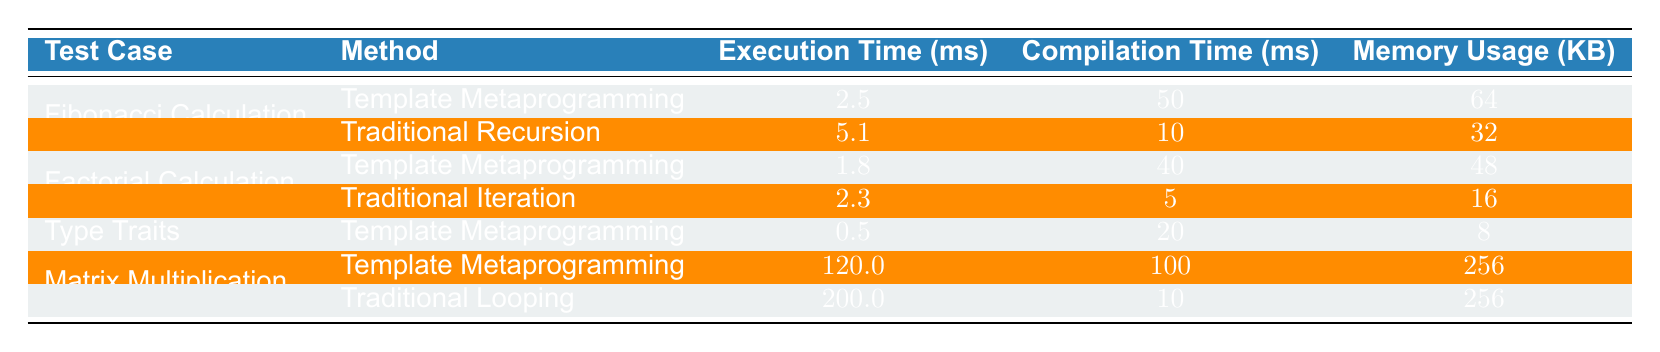What is the execution time for the `Factorial Calculation` using Template Metaprogramming? According to the table, for `Factorial Calculation` with `Template Metaprogramming`, the execution time is 1.8 ms.
Answer: 1.8 ms Which method has lower compilation time for `Matrix Multiplication`, Template Metaprogramming or Traditional Looping? The table shows that `Template Metaprogramming` has a compilation time of 100 ms, while `Traditional Looping` has a compilation time of 10 ms. Therefore, `Traditional Looping` has a lower compilation time.
Answer: Traditional Looping What is the average execution time of all the methods listed for `Fibonacci Calculation`? The execution times for `Fibonacci Calculation` are 2.5 ms (Template Metaprogramming) and 5.1 ms (Traditional Recursion). Summing these gives 2.5 + 5.1 = 7.6 ms. Dividing by 2 gives an average of 3.8 ms.
Answer: 3.8 ms Is the memory usage for Template Metaprogramming in `Factorial Calculation` greater than that for Traditional Iteration? The memory usage for `Template Metaprogramming` is 48 KB, and for `Traditional Iteration` it is 16 KB. Since 48 KB is greater than 16 KB, the answer is yes.
Answer: Yes What is the difference in execution time between `Matrix Multiplication` using Template Metaprogramming and Traditional Looping? The execution time for `Matrix Multiplication` using `Template Metaprogramming` is 120 ms, and for `Traditional Looping` it is 200 ms. Calculating the difference gives 200 - 120 = 80 ms.
Answer: 80 ms 